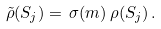<formula> <loc_0><loc_0><loc_500><loc_500>\tilde { \rho } ( S _ { j } ) = \, \sigma ( m ) \, \rho ( S _ { j } ) \, .</formula> 